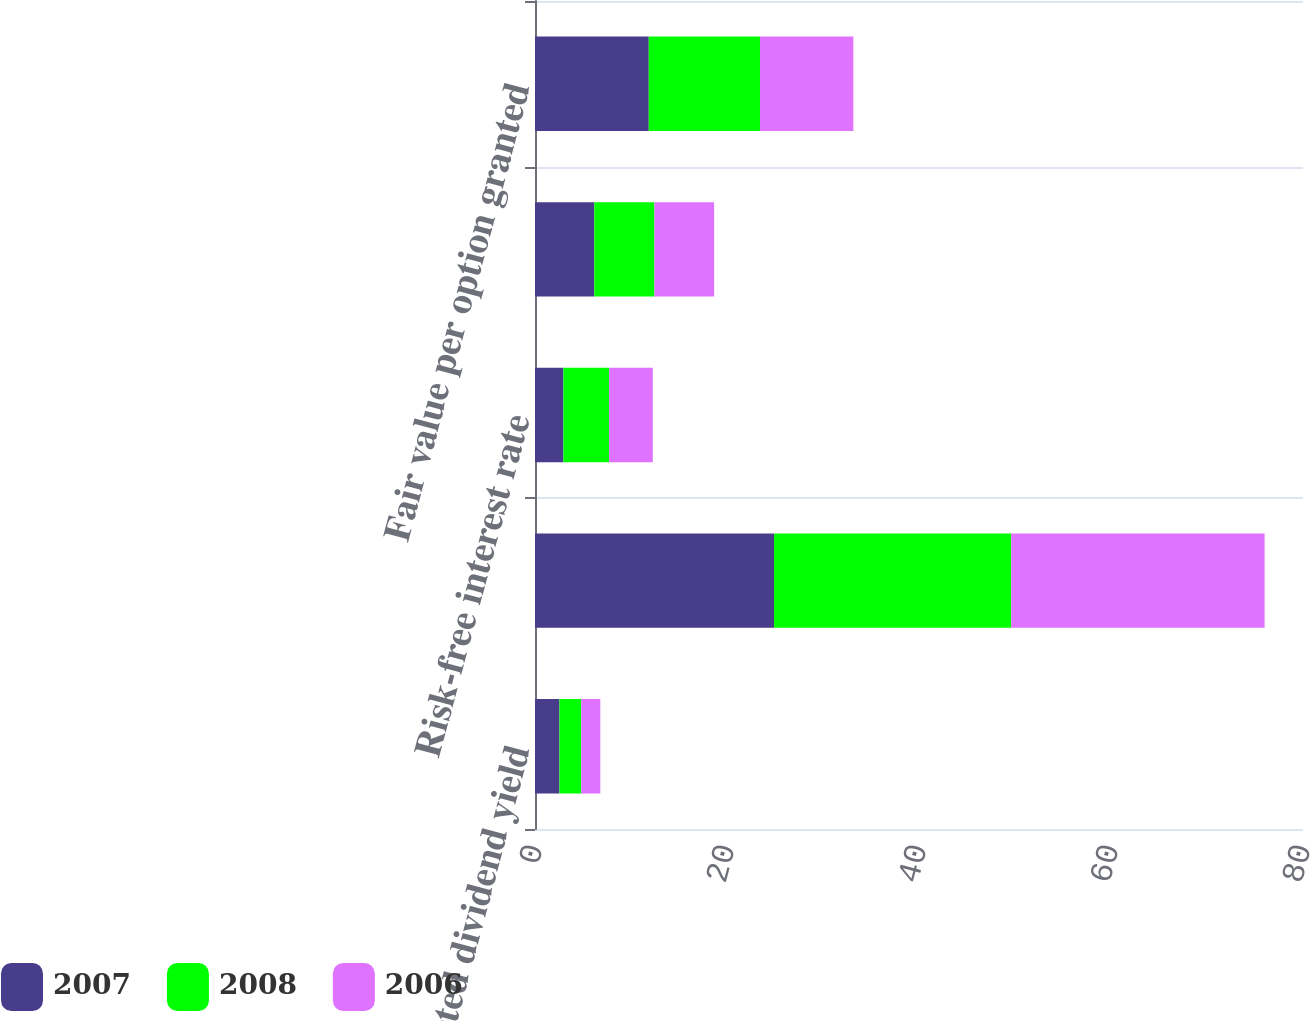<chart> <loc_0><loc_0><loc_500><loc_500><stacked_bar_chart><ecel><fcel>Expected dividend yield<fcel>Expected stock price<fcel>Risk-free interest rate<fcel>Expected life of options In<fcel>Fair value per option granted<nl><fcel>2007<fcel>2.55<fcel>24.9<fcel>2.96<fcel>6.18<fcel>11.85<nl><fcel>2008<fcel>2.26<fcel>24.7<fcel>4.76<fcel>6.26<fcel>11.59<nl><fcel>2006<fcel>1.99<fcel>26.4<fcel>4.55<fcel>6.22<fcel>9.72<nl></chart> 